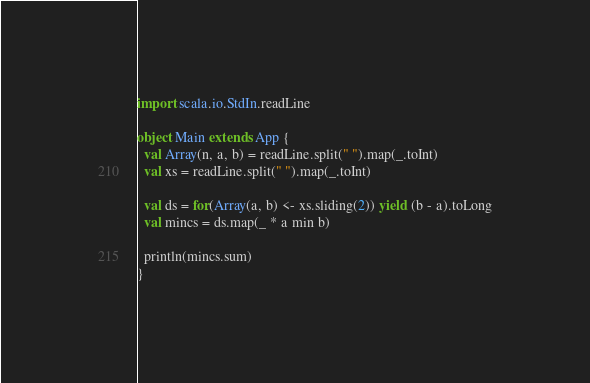<code> <loc_0><loc_0><loc_500><loc_500><_Scala_>import scala.io.StdIn.readLine

object Main extends App {
  val Array(n, a, b) = readLine.split(" ").map(_.toInt)
  val xs = readLine.split(" ").map(_.toInt)

  val ds = for(Array(a, b) <- xs.sliding(2)) yield (b - a).toLong
  val mincs = ds.map(_ * a min b)

  println(mincs.sum)
}
</code> 